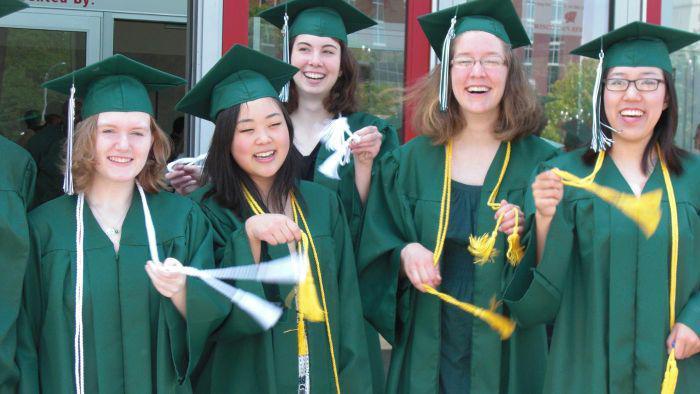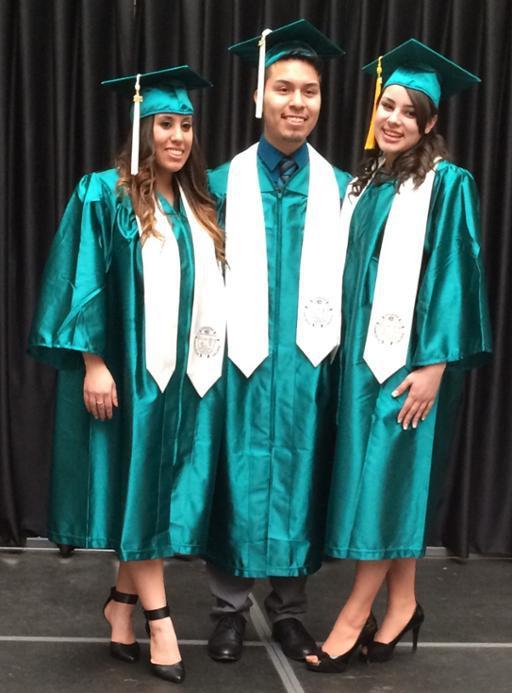The first image is the image on the left, the second image is the image on the right. Examine the images to the left and right. Is the description "One of the images shows only female graduating students." accurate? Answer yes or no. Yes. 